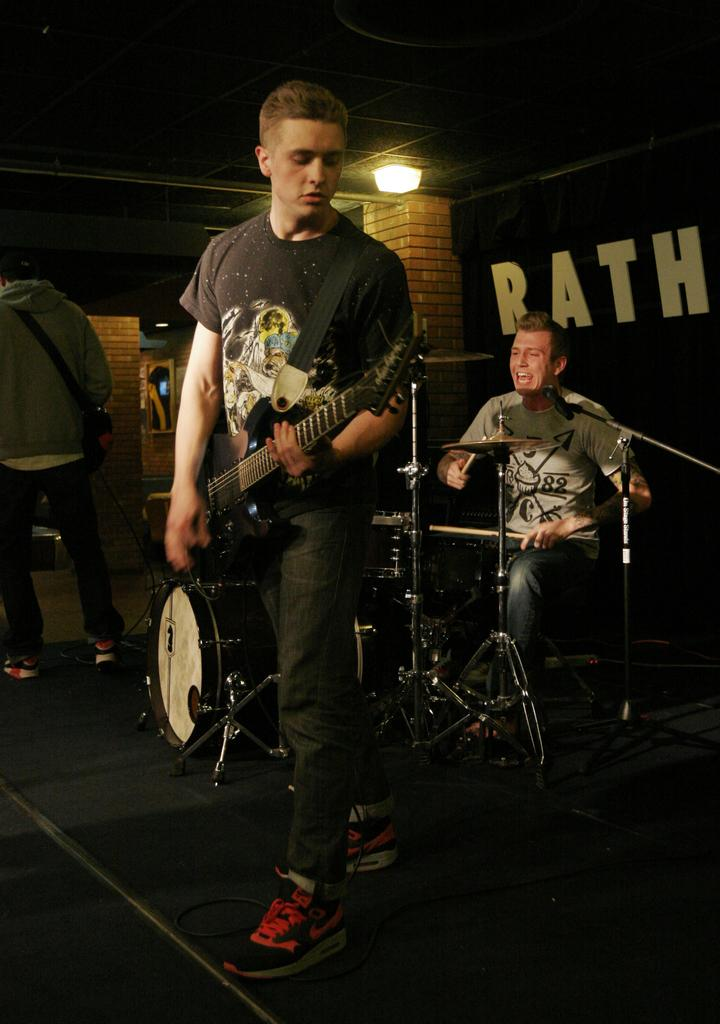What is the man in the image holding? The man is holding a guitar in the image. What is the man doing with the guitar? The man is playing the guitar. Can you describe the other person in the image? There is another man sitting in the image, and he is playing a musical instrument. What can be seen in the background of the image? There is a wall in the image, and a light is visible at the top. What type of knee injury is the man with the guitar experiencing in the image? There is no indication of a knee injury in the image; the man is playing the guitar without any visible issues. 